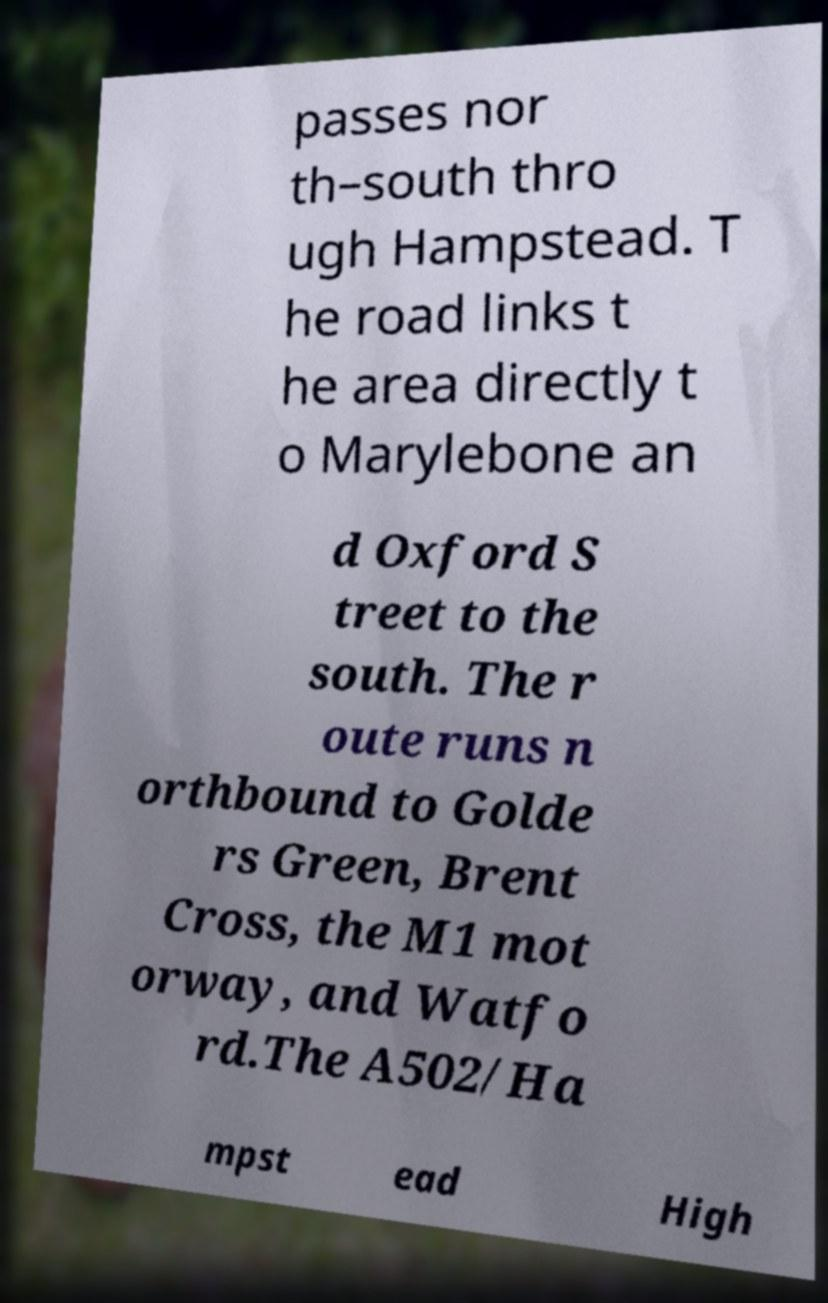I need the written content from this picture converted into text. Can you do that? passes nor th–south thro ugh Hampstead. T he road links t he area directly t o Marylebone an d Oxford S treet to the south. The r oute runs n orthbound to Golde rs Green, Brent Cross, the M1 mot orway, and Watfo rd.The A502/Ha mpst ead High 